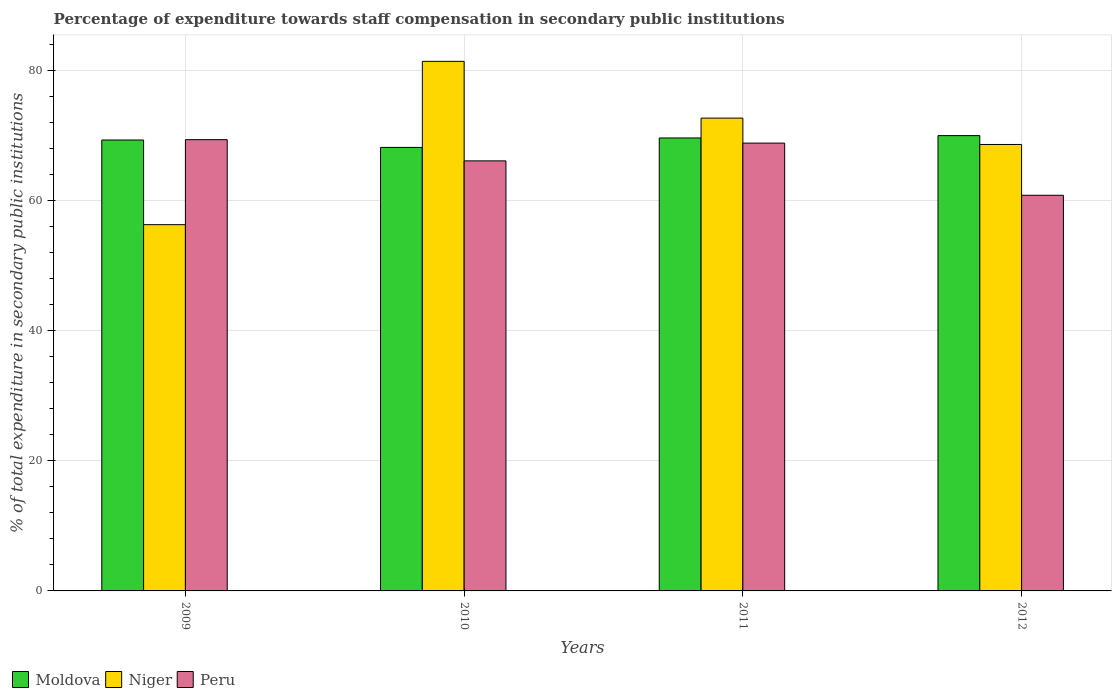How many different coloured bars are there?
Keep it short and to the point. 3. Are the number of bars on each tick of the X-axis equal?
Your response must be concise. Yes. How many bars are there on the 4th tick from the left?
Ensure brevity in your answer.  3. How many bars are there on the 1st tick from the right?
Your response must be concise. 3. What is the percentage of expenditure towards staff compensation in Peru in 2010?
Provide a succinct answer. 66.06. Across all years, what is the maximum percentage of expenditure towards staff compensation in Niger?
Give a very brief answer. 81.35. Across all years, what is the minimum percentage of expenditure towards staff compensation in Peru?
Give a very brief answer. 60.78. What is the total percentage of expenditure towards staff compensation in Peru in the graph?
Your answer should be compact. 264.95. What is the difference between the percentage of expenditure towards staff compensation in Moldova in 2010 and that in 2012?
Your response must be concise. -1.81. What is the difference between the percentage of expenditure towards staff compensation in Niger in 2010 and the percentage of expenditure towards staff compensation in Peru in 2012?
Offer a terse response. 20.57. What is the average percentage of expenditure towards staff compensation in Peru per year?
Provide a succinct answer. 66.24. In the year 2010, what is the difference between the percentage of expenditure towards staff compensation in Moldova and percentage of expenditure towards staff compensation in Peru?
Provide a short and direct response. 2.07. In how many years, is the percentage of expenditure towards staff compensation in Peru greater than 52 %?
Your answer should be compact. 4. What is the ratio of the percentage of expenditure towards staff compensation in Niger in 2009 to that in 2010?
Your response must be concise. 0.69. Is the percentage of expenditure towards staff compensation in Peru in 2010 less than that in 2011?
Ensure brevity in your answer.  Yes. What is the difference between the highest and the second highest percentage of expenditure towards staff compensation in Peru?
Your response must be concise. 0.53. What is the difference between the highest and the lowest percentage of expenditure towards staff compensation in Niger?
Keep it short and to the point. 25.09. In how many years, is the percentage of expenditure towards staff compensation in Peru greater than the average percentage of expenditure towards staff compensation in Peru taken over all years?
Your response must be concise. 2. Is the sum of the percentage of expenditure towards staff compensation in Niger in 2010 and 2011 greater than the maximum percentage of expenditure towards staff compensation in Moldova across all years?
Give a very brief answer. Yes. What does the 3rd bar from the left in 2011 represents?
Make the answer very short. Peru. What does the 1st bar from the right in 2012 represents?
Ensure brevity in your answer.  Peru. How many bars are there?
Provide a short and direct response. 12. Are all the bars in the graph horizontal?
Ensure brevity in your answer.  No. Where does the legend appear in the graph?
Offer a terse response. Bottom left. How many legend labels are there?
Offer a terse response. 3. What is the title of the graph?
Ensure brevity in your answer.  Percentage of expenditure towards staff compensation in secondary public institutions. What is the label or title of the X-axis?
Provide a succinct answer. Years. What is the label or title of the Y-axis?
Make the answer very short. % of total expenditure in secondary public institutions. What is the % of total expenditure in secondary public institutions of Moldova in 2009?
Ensure brevity in your answer.  69.27. What is the % of total expenditure in secondary public institutions in Niger in 2009?
Provide a succinct answer. 56.26. What is the % of total expenditure in secondary public institutions of Peru in 2009?
Provide a succinct answer. 69.32. What is the % of total expenditure in secondary public institutions in Moldova in 2010?
Your answer should be compact. 68.13. What is the % of total expenditure in secondary public institutions of Niger in 2010?
Provide a succinct answer. 81.35. What is the % of total expenditure in secondary public institutions of Peru in 2010?
Provide a short and direct response. 66.06. What is the % of total expenditure in secondary public institutions of Moldova in 2011?
Provide a short and direct response. 69.58. What is the % of total expenditure in secondary public institutions in Niger in 2011?
Your response must be concise. 72.63. What is the % of total expenditure in secondary public institutions in Peru in 2011?
Your answer should be very brief. 68.79. What is the % of total expenditure in secondary public institutions of Moldova in 2012?
Make the answer very short. 69.94. What is the % of total expenditure in secondary public institutions of Niger in 2012?
Give a very brief answer. 68.58. What is the % of total expenditure in secondary public institutions of Peru in 2012?
Make the answer very short. 60.78. Across all years, what is the maximum % of total expenditure in secondary public institutions of Moldova?
Your response must be concise. 69.94. Across all years, what is the maximum % of total expenditure in secondary public institutions in Niger?
Give a very brief answer. 81.35. Across all years, what is the maximum % of total expenditure in secondary public institutions in Peru?
Provide a succinct answer. 69.32. Across all years, what is the minimum % of total expenditure in secondary public institutions in Moldova?
Keep it short and to the point. 68.13. Across all years, what is the minimum % of total expenditure in secondary public institutions of Niger?
Provide a succinct answer. 56.26. Across all years, what is the minimum % of total expenditure in secondary public institutions of Peru?
Offer a very short reply. 60.78. What is the total % of total expenditure in secondary public institutions of Moldova in the graph?
Offer a terse response. 276.91. What is the total % of total expenditure in secondary public institutions in Niger in the graph?
Ensure brevity in your answer.  278.82. What is the total % of total expenditure in secondary public institutions of Peru in the graph?
Your answer should be very brief. 264.95. What is the difference between the % of total expenditure in secondary public institutions of Moldova in 2009 and that in 2010?
Provide a short and direct response. 1.14. What is the difference between the % of total expenditure in secondary public institutions of Niger in 2009 and that in 2010?
Provide a short and direct response. -25.09. What is the difference between the % of total expenditure in secondary public institutions of Peru in 2009 and that in 2010?
Provide a short and direct response. 3.26. What is the difference between the % of total expenditure in secondary public institutions of Moldova in 2009 and that in 2011?
Your answer should be very brief. -0.31. What is the difference between the % of total expenditure in secondary public institutions in Niger in 2009 and that in 2011?
Provide a succinct answer. -16.37. What is the difference between the % of total expenditure in secondary public institutions in Peru in 2009 and that in 2011?
Ensure brevity in your answer.  0.53. What is the difference between the % of total expenditure in secondary public institutions in Moldova in 2009 and that in 2012?
Make the answer very short. -0.68. What is the difference between the % of total expenditure in secondary public institutions of Niger in 2009 and that in 2012?
Provide a succinct answer. -12.32. What is the difference between the % of total expenditure in secondary public institutions in Peru in 2009 and that in 2012?
Provide a succinct answer. 8.54. What is the difference between the % of total expenditure in secondary public institutions of Moldova in 2010 and that in 2011?
Your answer should be very brief. -1.45. What is the difference between the % of total expenditure in secondary public institutions of Niger in 2010 and that in 2011?
Offer a terse response. 8.72. What is the difference between the % of total expenditure in secondary public institutions of Peru in 2010 and that in 2011?
Ensure brevity in your answer.  -2.73. What is the difference between the % of total expenditure in secondary public institutions of Moldova in 2010 and that in 2012?
Keep it short and to the point. -1.81. What is the difference between the % of total expenditure in secondary public institutions in Niger in 2010 and that in 2012?
Provide a short and direct response. 12.77. What is the difference between the % of total expenditure in secondary public institutions of Peru in 2010 and that in 2012?
Your answer should be very brief. 5.28. What is the difference between the % of total expenditure in secondary public institutions in Moldova in 2011 and that in 2012?
Your response must be concise. -0.36. What is the difference between the % of total expenditure in secondary public institutions of Niger in 2011 and that in 2012?
Your answer should be very brief. 4.05. What is the difference between the % of total expenditure in secondary public institutions in Peru in 2011 and that in 2012?
Give a very brief answer. 8.01. What is the difference between the % of total expenditure in secondary public institutions in Moldova in 2009 and the % of total expenditure in secondary public institutions in Niger in 2010?
Your response must be concise. -12.08. What is the difference between the % of total expenditure in secondary public institutions in Moldova in 2009 and the % of total expenditure in secondary public institutions in Peru in 2010?
Make the answer very short. 3.2. What is the difference between the % of total expenditure in secondary public institutions of Niger in 2009 and the % of total expenditure in secondary public institutions of Peru in 2010?
Make the answer very short. -9.8. What is the difference between the % of total expenditure in secondary public institutions of Moldova in 2009 and the % of total expenditure in secondary public institutions of Niger in 2011?
Offer a very short reply. -3.36. What is the difference between the % of total expenditure in secondary public institutions in Moldova in 2009 and the % of total expenditure in secondary public institutions in Peru in 2011?
Ensure brevity in your answer.  0.48. What is the difference between the % of total expenditure in secondary public institutions in Niger in 2009 and the % of total expenditure in secondary public institutions in Peru in 2011?
Provide a short and direct response. -12.53. What is the difference between the % of total expenditure in secondary public institutions of Moldova in 2009 and the % of total expenditure in secondary public institutions of Niger in 2012?
Offer a terse response. 0.69. What is the difference between the % of total expenditure in secondary public institutions of Moldova in 2009 and the % of total expenditure in secondary public institutions of Peru in 2012?
Your answer should be compact. 8.49. What is the difference between the % of total expenditure in secondary public institutions in Niger in 2009 and the % of total expenditure in secondary public institutions in Peru in 2012?
Provide a succinct answer. -4.52. What is the difference between the % of total expenditure in secondary public institutions in Moldova in 2010 and the % of total expenditure in secondary public institutions in Niger in 2011?
Make the answer very short. -4.5. What is the difference between the % of total expenditure in secondary public institutions of Moldova in 2010 and the % of total expenditure in secondary public institutions of Peru in 2011?
Provide a short and direct response. -0.66. What is the difference between the % of total expenditure in secondary public institutions of Niger in 2010 and the % of total expenditure in secondary public institutions of Peru in 2011?
Your answer should be very brief. 12.56. What is the difference between the % of total expenditure in secondary public institutions in Moldova in 2010 and the % of total expenditure in secondary public institutions in Niger in 2012?
Keep it short and to the point. -0.45. What is the difference between the % of total expenditure in secondary public institutions in Moldova in 2010 and the % of total expenditure in secondary public institutions in Peru in 2012?
Offer a very short reply. 7.35. What is the difference between the % of total expenditure in secondary public institutions in Niger in 2010 and the % of total expenditure in secondary public institutions in Peru in 2012?
Give a very brief answer. 20.57. What is the difference between the % of total expenditure in secondary public institutions of Moldova in 2011 and the % of total expenditure in secondary public institutions of Niger in 2012?
Your answer should be very brief. 1. What is the difference between the % of total expenditure in secondary public institutions in Moldova in 2011 and the % of total expenditure in secondary public institutions in Peru in 2012?
Offer a terse response. 8.8. What is the difference between the % of total expenditure in secondary public institutions of Niger in 2011 and the % of total expenditure in secondary public institutions of Peru in 2012?
Give a very brief answer. 11.85. What is the average % of total expenditure in secondary public institutions in Moldova per year?
Your answer should be compact. 69.23. What is the average % of total expenditure in secondary public institutions in Niger per year?
Offer a very short reply. 69.7. What is the average % of total expenditure in secondary public institutions in Peru per year?
Provide a short and direct response. 66.24. In the year 2009, what is the difference between the % of total expenditure in secondary public institutions in Moldova and % of total expenditure in secondary public institutions in Niger?
Make the answer very short. 13. In the year 2009, what is the difference between the % of total expenditure in secondary public institutions of Moldova and % of total expenditure in secondary public institutions of Peru?
Provide a short and direct response. -0.05. In the year 2009, what is the difference between the % of total expenditure in secondary public institutions of Niger and % of total expenditure in secondary public institutions of Peru?
Ensure brevity in your answer.  -13.06. In the year 2010, what is the difference between the % of total expenditure in secondary public institutions of Moldova and % of total expenditure in secondary public institutions of Niger?
Provide a succinct answer. -13.22. In the year 2010, what is the difference between the % of total expenditure in secondary public institutions in Moldova and % of total expenditure in secondary public institutions in Peru?
Offer a terse response. 2.07. In the year 2010, what is the difference between the % of total expenditure in secondary public institutions in Niger and % of total expenditure in secondary public institutions in Peru?
Offer a terse response. 15.29. In the year 2011, what is the difference between the % of total expenditure in secondary public institutions in Moldova and % of total expenditure in secondary public institutions in Niger?
Offer a very short reply. -3.05. In the year 2011, what is the difference between the % of total expenditure in secondary public institutions of Moldova and % of total expenditure in secondary public institutions of Peru?
Make the answer very short. 0.79. In the year 2011, what is the difference between the % of total expenditure in secondary public institutions of Niger and % of total expenditure in secondary public institutions of Peru?
Your answer should be very brief. 3.84. In the year 2012, what is the difference between the % of total expenditure in secondary public institutions of Moldova and % of total expenditure in secondary public institutions of Niger?
Offer a terse response. 1.36. In the year 2012, what is the difference between the % of total expenditure in secondary public institutions of Moldova and % of total expenditure in secondary public institutions of Peru?
Provide a short and direct response. 9.16. In the year 2012, what is the difference between the % of total expenditure in secondary public institutions of Niger and % of total expenditure in secondary public institutions of Peru?
Offer a very short reply. 7.8. What is the ratio of the % of total expenditure in secondary public institutions of Moldova in 2009 to that in 2010?
Make the answer very short. 1.02. What is the ratio of the % of total expenditure in secondary public institutions of Niger in 2009 to that in 2010?
Provide a short and direct response. 0.69. What is the ratio of the % of total expenditure in secondary public institutions in Peru in 2009 to that in 2010?
Provide a short and direct response. 1.05. What is the ratio of the % of total expenditure in secondary public institutions in Niger in 2009 to that in 2011?
Provide a short and direct response. 0.77. What is the ratio of the % of total expenditure in secondary public institutions in Peru in 2009 to that in 2011?
Give a very brief answer. 1.01. What is the ratio of the % of total expenditure in secondary public institutions of Moldova in 2009 to that in 2012?
Give a very brief answer. 0.99. What is the ratio of the % of total expenditure in secondary public institutions of Niger in 2009 to that in 2012?
Your response must be concise. 0.82. What is the ratio of the % of total expenditure in secondary public institutions in Peru in 2009 to that in 2012?
Make the answer very short. 1.14. What is the ratio of the % of total expenditure in secondary public institutions of Moldova in 2010 to that in 2011?
Your response must be concise. 0.98. What is the ratio of the % of total expenditure in secondary public institutions in Niger in 2010 to that in 2011?
Your answer should be very brief. 1.12. What is the ratio of the % of total expenditure in secondary public institutions of Peru in 2010 to that in 2011?
Offer a terse response. 0.96. What is the ratio of the % of total expenditure in secondary public institutions in Moldova in 2010 to that in 2012?
Provide a succinct answer. 0.97. What is the ratio of the % of total expenditure in secondary public institutions of Niger in 2010 to that in 2012?
Make the answer very short. 1.19. What is the ratio of the % of total expenditure in secondary public institutions in Peru in 2010 to that in 2012?
Your answer should be compact. 1.09. What is the ratio of the % of total expenditure in secondary public institutions of Niger in 2011 to that in 2012?
Give a very brief answer. 1.06. What is the ratio of the % of total expenditure in secondary public institutions of Peru in 2011 to that in 2012?
Your answer should be compact. 1.13. What is the difference between the highest and the second highest % of total expenditure in secondary public institutions of Moldova?
Ensure brevity in your answer.  0.36. What is the difference between the highest and the second highest % of total expenditure in secondary public institutions in Niger?
Your answer should be compact. 8.72. What is the difference between the highest and the second highest % of total expenditure in secondary public institutions in Peru?
Your answer should be very brief. 0.53. What is the difference between the highest and the lowest % of total expenditure in secondary public institutions in Moldova?
Make the answer very short. 1.81. What is the difference between the highest and the lowest % of total expenditure in secondary public institutions of Niger?
Provide a succinct answer. 25.09. What is the difference between the highest and the lowest % of total expenditure in secondary public institutions in Peru?
Give a very brief answer. 8.54. 